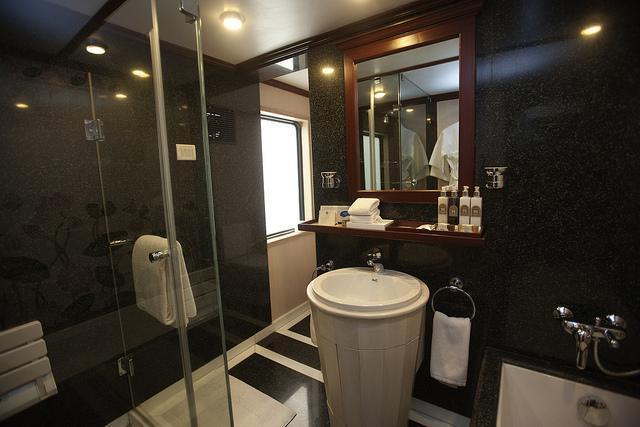What is most likely outside the doorway?
Pick the correct solution from the four options below to address the question.
Options: Bedroom, living room, kitchen, garage. Bedroom. What shape is the mirror hanging on the wall with some wooden planks?
Make your selection and explain in format: 'Answer: answer
Rationale: rationale.'
Options: Circle, rectangle, square, oval. Answer: rectangle.
Rationale: The mirror is not curved. it does not have equal sides. 